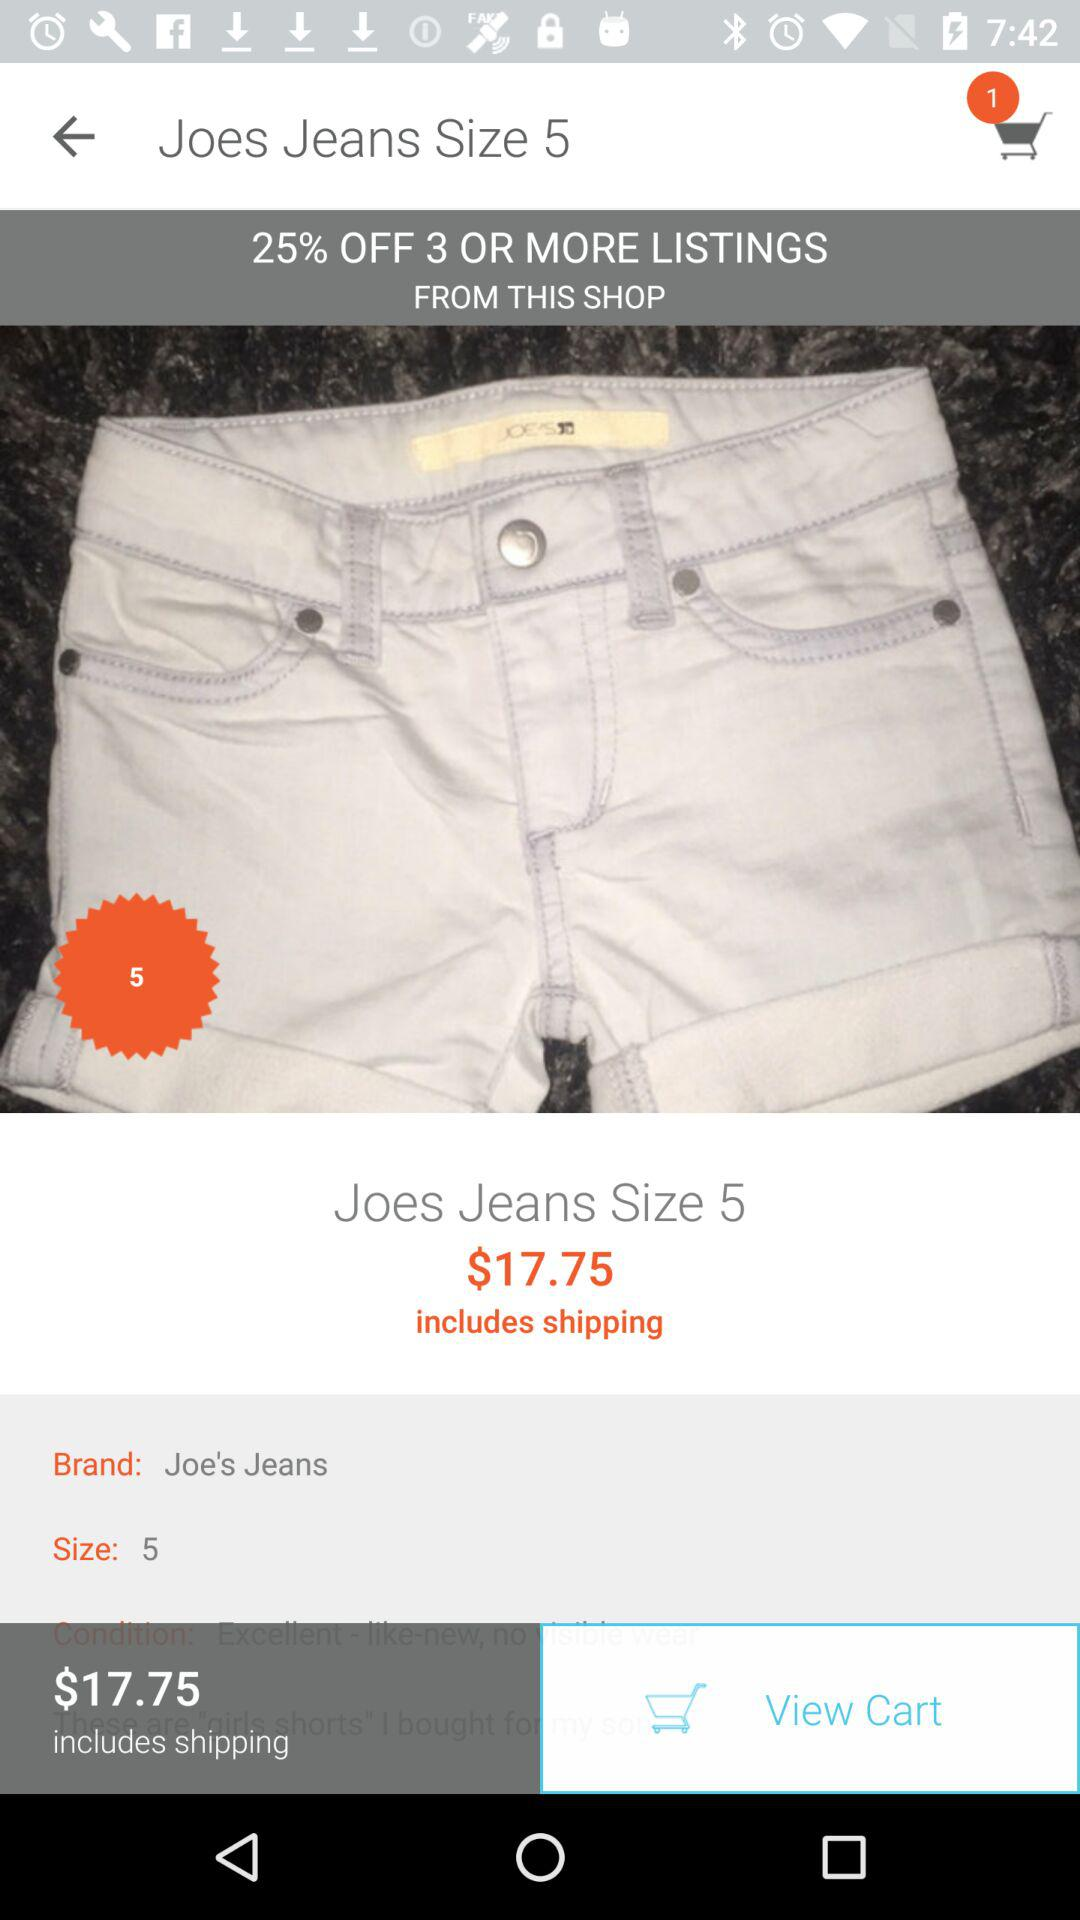What's the number of items in the cart? The number of items is 1. 